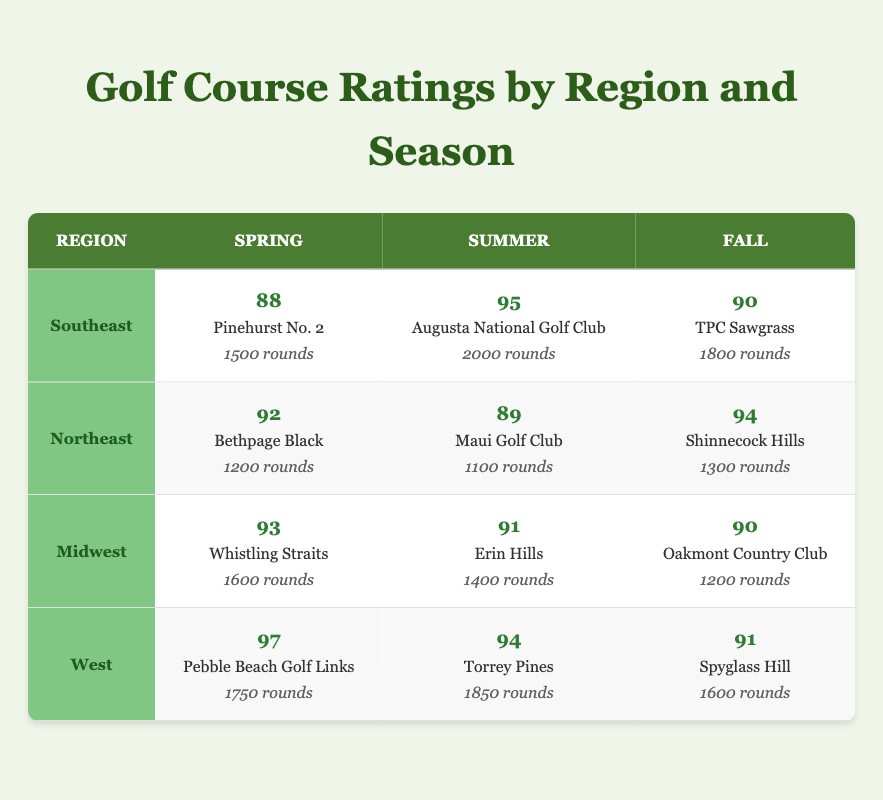What is the highest rating and which course received it? By examining the table, the highest rating is 97, given to Pebble Beach Golf Links in the West region during Spring.
Answer: 97, Pebble Beach Golf Links Which region has the lowest average rating across all seasons? To find the lowest average rating, we can calculate the average for each region: Southeast (91), Northeast (91.67), Midwest (91.33), and West (94). Southeast has the lowest average of 91.
Answer: Southeast How many total rounds were played in Northeast region during Summer? Looking at the Summer column for the Northeast region, it shows Maui Golf Club with 1100 rounds. Thus, the total rounds played in this region during Summer is 1100.
Answer: 1100 Is the rating for TPC Sawgrass higher than that for Erin Hills? TPC Sawgrass has a rating of 90, while Erin Hills has a rating of 91. Since 90 is less than 91, the statement is false.
Answer: No What is the difference in the number of rounds played between Pinehurst No. 2 and Oakmont Country Club? Pinehurst No. 2 had 1500 rounds, while Oakmont Country Club had 1200 rounds. The difference in rounds is 1500 - 1200 = 300.
Answer: 300 Which course in the West region had the lowest rating and how many rounds were played there? In the West region, Spyglass Hill had the lowest rating of 91. It had 1600 rounds played.
Answer: Spyglass Hill, 91, 1600 What is the average rating for Fall courses across all regions? The ratings for Fall courses are 90 (Southeast), 94 (Northeast), 90 (Midwest), and 91 (West). The average is (90+94+90+91)/4 = 91.25.
Answer: 91.25 Which region had the highest rated course during Summer? In the Summer season, Augusta National Golf Club in the Southeast had the highest rating of 95 compared to 89 (Northeast), 91 (Midwest), and 94 (West).
Answer: Southeast, 95 Were there any courses in the Midwest region with a rating higher than 92? Examining the Midwest ratings: Whistling Straits (93), Erin Hills (91), and Oakmont Country Club (90). Only Whistling Straits exceeded 92, so the answer is yes.
Answer: Yes 